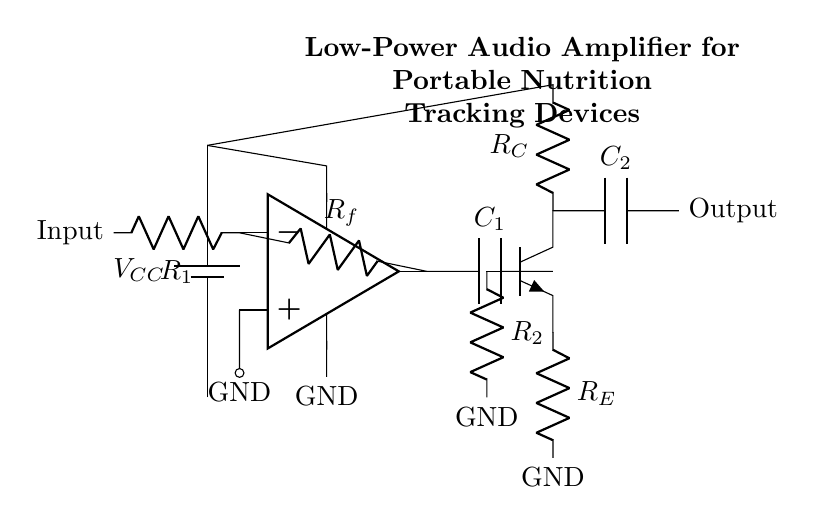What is the power supply voltage in this circuit? The circuit diagram contains a symbol for a battery labeled V_CC, which indicates the power supply voltage. It is common in low-power circuits for this voltage to be state at 5 volts, which is typical for many audio applications.
Answer: 5 volts What type of amplifier is represented in this diagram? The circuit shows an operational amplifier symbol, indicating that this is an operational amplifier circuit used for signal amplification. Upon reviewing the connections, it's also evident that it is set up as a non-inverting amplifier.
Answer: Operational amplifier What components are connected to the output of the operational amplifier? From the diagram, you can see that the output of the operational amplifier connects to a capacitor (C1) and then to a transistor (Q1). Therefore, it is clear that a capacitor and a transistor are directly connected.
Answer: Capacitor and transistor Which resistors are part of the input stage? The input stage is primarily made up of two resistors: R1 and R_f. R1 is connected to the input of the operational amplifier and R_f is connected between the output and the inverting input of the operational amplifier, establishing a feedback loop.
Answer: R1 and R_f What is the purpose of the capacitor labeled C1 in this circuit? The capacitor C1 is connected to the output of the operational amplifier and serves to couple the audio signal, allowing AC signals to pass while blocking any DC offset. This is a common design in audio devices to ensure clean signal transmission.
Answer: Coupling capacitor 